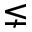<formula> <loc_0><loc_0><loc_500><loc_500>\lneq</formula> 